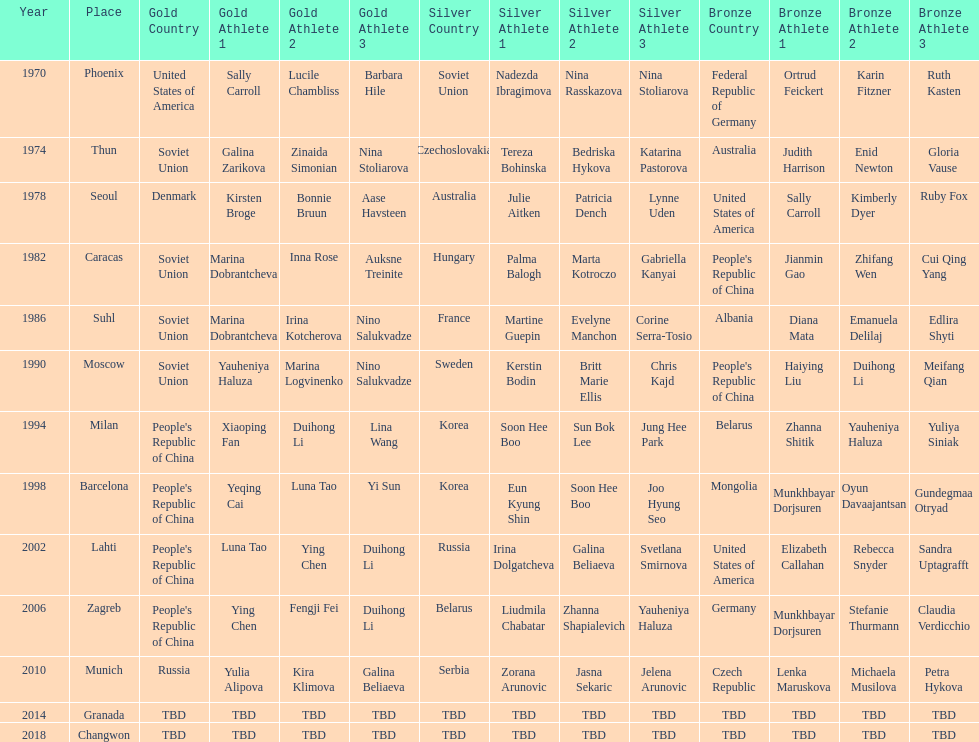Whose name is listed before bonnie bruun's in the gold column? Kirsten Broge. 